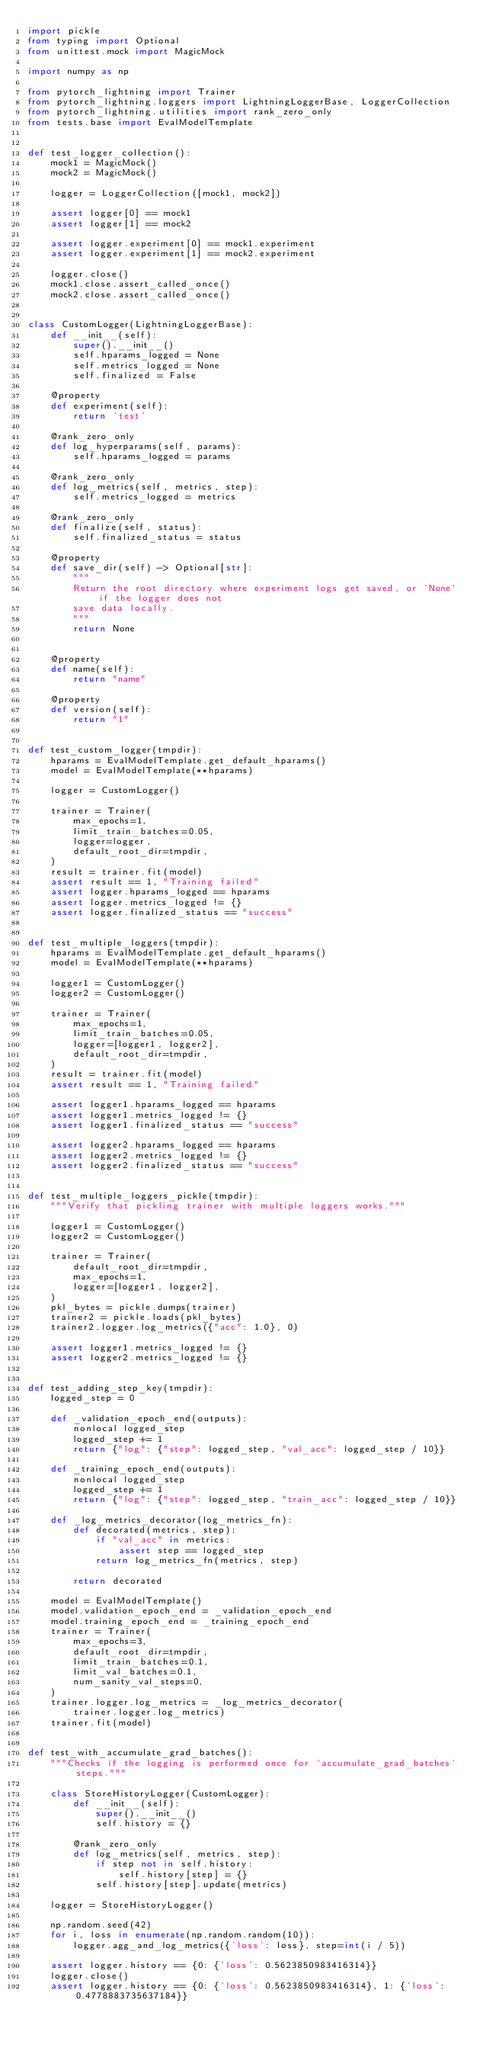<code> <loc_0><loc_0><loc_500><loc_500><_Python_>import pickle
from typing import Optional
from unittest.mock import MagicMock

import numpy as np

from pytorch_lightning import Trainer
from pytorch_lightning.loggers import LightningLoggerBase, LoggerCollection
from pytorch_lightning.utilities import rank_zero_only
from tests.base import EvalModelTemplate


def test_logger_collection():
    mock1 = MagicMock()
    mock2 = MagicMock()

    logger = LoggerCollection([mock1, mock2])

    assert logger[0] == mock1
    assert logger[1] == mock2

    assert logger.experiment[0] == mock1.experiment
    assert logger.experiment[1] == mock2.experiment

    logger.close()
    mock1.close.assert_called_once()
    mock2.close.assert_called_once()


class CustomLogger(LightningLoggerBase):
    def __init__(self):
        super().__init__()
        self.hparams_logged = None
        self.metrics_logged = None
        self.finalized = False

    @property
    def experiment(self):
        return 'test'

    @rank_zero_only
    def log_hyperparams(self, params):
        self.hparams_logged = params

    @rank_zero_only
    def log_metrics(self, metrics, step):
        self.metrics_logged = metrics

    @rank_zero_only
    def finalize(self, status):
        self.finalized_status = status

    @property
    def save_dir(self) -> Optional[str]:
        """
        Return the root directory where experiment logs get saved, or `None` if the logger does not
        save data locally.
        """
        return None


    @property
    def name(self):
        return "name"

    @property
    def version(self):
        return "1"


def test_custom_logger(tmpdir):
    hparams = EvalModelTemplate.get_default_hparams()
    model = EvalModelTemplate(**hparams)

    logger = CustomLogger()

    trainer = Trainer(
        max_epochs=1,
        limit_train_batches=0.05,
        logger=logger,
        default_root_dir=tmpdir,
    )
    result = trainer.fit(model)
    assert result == 1, "Training failed"
    assert logger.hparams_logged == hparams
    assert logger.metrics_logged != {}
    assert logger.finalized_status == "success"


def test_multiple_loggers(tmpdir):
    hparams = EvalModelTemplate.get_default_hparams()
    model = EvalModelTemplate(**hparams)

    logger1 = CustomLogger()
    logger2 = CustomLogger()

    trainer = Trainer(
        max_epochs=1,
        limit_train_batches=0.05,
        logger=[logger1, logger2],
        default_root_dir=tmpdir,
    )
    result = trainer.fit(model)
    assert result == 1, "Training failed"

    assert logger1.hparams_logged == hparams
    assert logger1.metrics_logged != {}
    assert logger1.finalized_status == "success"

    assert logger2.hparams_logged == hparams
    assert logger2.metrics_logged != {}
    assert logger2.finalized_status == "success"


def test_multiple_loggers_pickle(tmpdir):
    """Verify that pickling trainer with multiple loggers works."""

    logger1 = CustomLogger()
    logger2 = CustomLogger()

    trainer = Trainer(
        default_root_dir=tmpdir,
        max_epochs=1,
        logger=[logger1, logger2],
    )
    pkl_bytes = pickle.dumps(trainer)
    trainer2 = pickle.loads(pkl_bytes)
    trainer2.logger.log_metrics({"acc": 1.0}, 0)

    assert logger1.metrics_logged != {}
    assert logger2.metrics_logged != {}


def test_adding_step_key(tmpdir):
    logged_step = 0

    def _validation_epoch_end(outputs):
        nonlocal logged_step
        logged_step += 1
        return {"log": {"step": logged_step, "val_acc": logged_step / 10}}

    def _training_epoch_end(outputs):
        nonlocal logged_step
        logged_step += 1
        return {"log": {"step": logged_step, "train_acc": logged_step / 10}}

    def _log_metrics_decorator(log_metrics_fn):
        def decorated(metrics, step):
            if "val_acc" in metrics:
                assert step == logged_step
            return log_metrics_fn(metrics, step)

        return decorated

    model = EvalModelTemplate()
    model.validation_epoch_end = _validation_epoch_end
    model.training_epoch_end = _training_epoch_end
    trainer = Trainer(
        max_epochs=3,
        default_root_dir=tmpdir,
        limit_train_batches=0.1,
        limit_val_batches=0.1,
        num_sanity_val_steps=0,
    )
    trainer.logger.log_metrics = _log_metrics_decorator(
        trainer.logger.log_metrics)
    trainer.fit(model)


def test_with_accumulate_grad_batches():
    """Checks if the logging is performed once for `accumulate_grad_batches` steps."""

    class StoreHistoryLogger(CustomLogger):
        def __init__(self):
            super().__init__()
            self.history = {}

        @rank_zero_only
        def log_metrics(self, metrics, step):
            if step not in self.history:
                self.history[step] = {}
            self.history[step].update(metrics)

    logger = StoreHistoryLogger()

    np.random.seed(42)
    for i, loss in enumerate(np.random.random(10)):
        logger.agg_and_log_metrics({'loss': loss}, step=int(i / 5))

    assert logger.history == {0: {'loss': 0.5623850983416314}}
    logger.close()
    assert logger.history == {0: {'loss': 0.5623850983416314}, 1: {'loss': 0.4778883735637184}}
</code> 